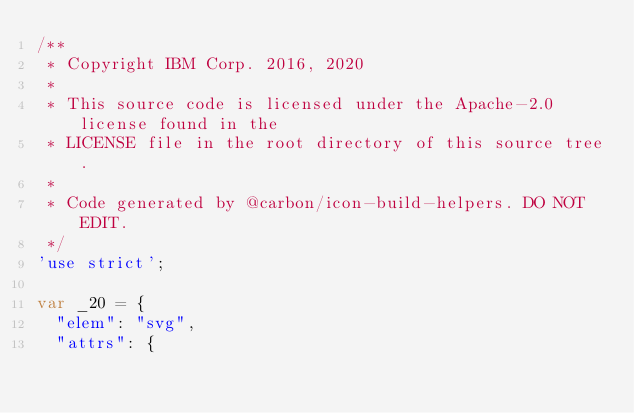Convert code to text. <code><loc_0><loc_0><loc_500><loc_500><_JavaScript_>/**
 * Copyright IBM Corp. 2016, 2020
 *
 * This source code is licensed under the Apache-2.0 license found in the
 * LICENSE file in the root directory of this source tree.
 *
 * Code generated by @carbon/icon-build-helpers. DO NOT EDIT.
 */
'use strict';

var _20 = {
  "elem": "svg",
  "attrs": {</code> 